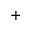<formula> <loc_0><loc_0><loc_500><loc_500>^ { + }</formula> 